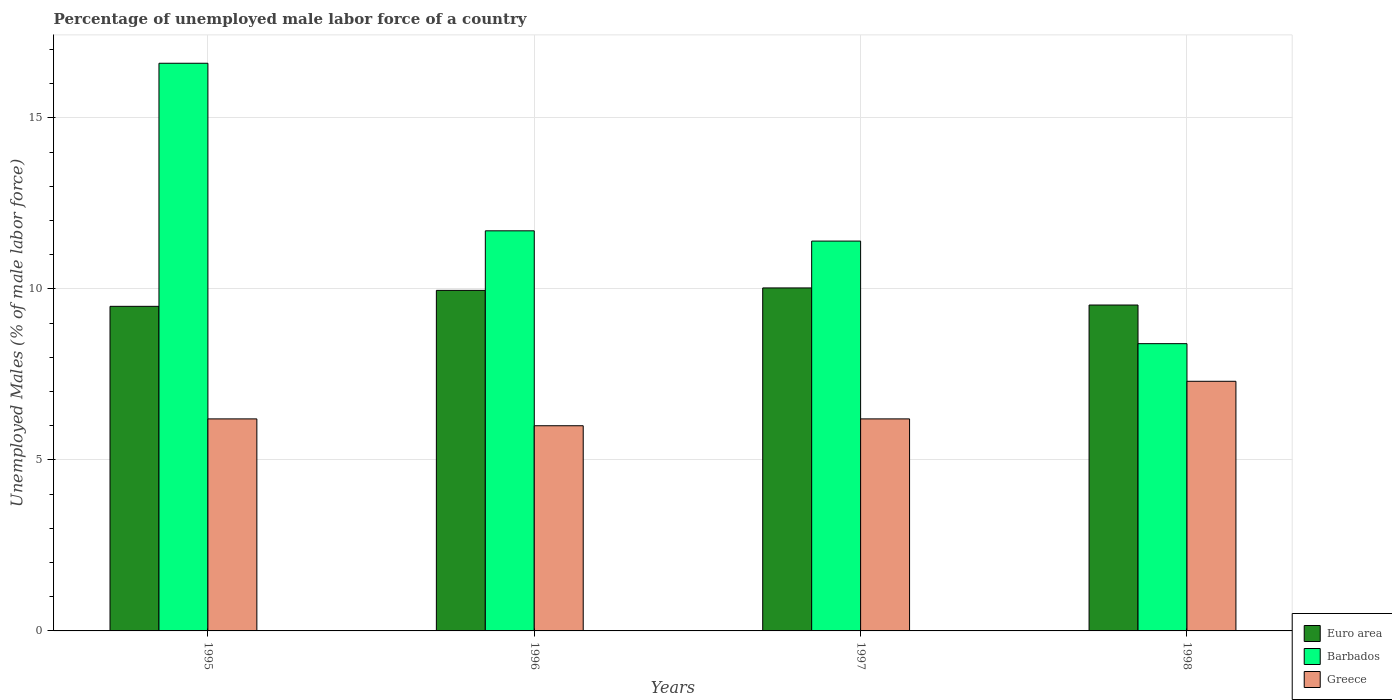How many groups of bars are there?
Provide a succinct answer. 4. Are the number of bars per tick equal to the number of legend labels?
Your answer should be very brief. Yes. Are the number of bars on each tick of the X-axis equal?
Provide a short and direct response. Yes. In how many cases, is the number of bars for a given year not equal to the number of legend labels?
Your answer should be compact. 0. What is the percentage of unemployed male labor force in Barbados in 1995?
Keep it short and to the point. 16.6. Across all years, what is the maximum percentage of unemployed male labor force in Greece?
Ensure brevity in your answer.  7.3. What is the total percentage of unemployed male labor force in Barbados in the graph?
Offer a terse response. 48.1. What is the difference between the percentage of unemployed male labor force in Euro area in 1996 and that in 1997?
Your response must be concise. -0.07. What is the difference between the percentage of unemployed male labor force in Euro area in 1998 and the percentage of unemployed male labor force in Barbados in 1996?
Make the answer very short. -2.17. What is the average percentage of unemployed male labor force in Barbados per year?
Your response must be concise. 12.02. In the year 1995, what is the difference between the percentage of unemployed male labor force in Greece and percentage of unemployed male labor force in Barbados?
Keep it short and to the point. -10.4. What is the ratio of the percentage of unemployed male labor force in Euro area in 1996 to that in 1998?
Offer a terse response. 1.04. Is the percentage of unemployed male labor force in Euro area in 1996 less than that in 1998?
Make the answer very short. No. Is the difference between the percentage of unemployed male labor force in Greece in 1995 and 1998 greater than the difference between the percentage of unemployed male labor force in Barbados in 1995 and 1998?
Offer a terse response. No. What is the difference between the highest and the second highest percentage of unemployed male labor force in Barbados?
Offer a terse response. 4.9. What is the difference between the highest and the lowest percentage of unemployed male labor force in Barbados?
Ensure brevity in your answer.  8.2. In how many years, is the percentage of unemployed male labor force in Barbados greater than the average percentage of unemployed male labor force in Barbados taken over all years?
Ensure brevity in your answer.  1. What does the 3rd bar from the left in 1996 represents?
Provide a short and direct response. Greece. What does the 2nd bar from the right in 1997 represents?
Your response must be concise. Barbados. Is it the case that in every year, the sum of the percentage of unemployed male labor force in Barbados and percentage of unemployed male labor force in Greece is greater than the percentage of unemployed male labor force in Euro area?
Ensure brevity in your answer.  Yes. How many bars are there?
Offer a very short reply. 12. Are all the bars in the graph horizontal?
Your answer should be very brief. No. How many years are there in the graph?
Offer a terse response. 4. What is the difference between two consecutive major ticks on the Y-axis?
Give a very brief answer. 5. Are the values on the major ticks of Y-axis written in scientific E-notation?
Ensure brevity in your answer.  No. Does the graph contain any zero values?
Give a very brief answer. No. Does the graph contain grids?
Your answer should be compact. Yes. Where does the legend appear in the graph?
Keep it short and to the point. Bottom right. How are the legend labels stacked?
Keep it short and to the point. Vertical. What is the title of the graph?
Make the answer very short. Percentage of unemployed male labor force of a country. What is the label or title of the Y-axis?
Your response must be concise. Unemployed Males (% of male labor force). What is the Unemployed Males (% of male labor force) in Euro area in 1995?
Offer a very short reply. 9.49. What is the Unemployed Males (% of male labor force) in Barbados in 1995?
Give a very brief answer. 16.6. What is the Unemployed Males (% of male labor force) in Greece in 1995?
Make the answer very short. 6.2. What is the Unemployed Males (% of male labor force) in Euro area in 1996?
Give a very brief answer. 9.96. What is the Unemployed Males (% of male labor force) of Barbados in 1996?
Provide a succinct answer. 11.7. What is the Unemployed Males (% of male labor force) in Euro area in 1997?
Offer a very short reply. 10.03. What is the Unemployed Males (% of male labor force) of Barbados in 1997?
Offer a terse response. 11.4. What is the Unemployed Males (% of male labor force) in Greece in 1997?
Provide a succinct answer. 6.2. What is the Unemployed Males (% of male labor force) in Euro area in 1998?
Make the answer very short. 9.53. What is the Unemployed Males (% of male labor force) in Barbados in 1998?
Offer a very short reply. 8.4. What is the Unemployed Males (% of male labor force) of Greece in 1998?
Keep it short and to the point. 7.3. Across all years, what is the maximum Unemployed Males (% of male labor force) in Euro area?
Keep it short and to the point. 10.03. Across all years, what is the maximum Unemployed Males (% of male labor force) in Barbados?
Ensure brevity in your answer.  16.6. Across all years, what is the maximum Unemployed Males (% of male labor force) of Greece?
Provide a short and direct response. 7.3. Across all years, what is the minimum Unemployed Males (% of male labor force) in Euro area?
Your response must be concise. 9.49. Across all years, what is the minimum Unemployed Males (% of male labor force) in Barbados?
Make the answer very short. 8.4. Across all years, what is the minimum Unemployed Males (% of male labor force) in Greece?
Give a very brief answer. 6. What is the total Unemployed Males (% of male labor force) in Euro area in the graph?
Provide a short and direct response. 39.01. What is the total Unemployed Males (% of male labor force) of Barbados in the graph?
Offer a terse response. 48.1. What is the total Unemployed Males (% of male labor force) in Greece in the graph?
Provide a succinct answer. 25.7. What is the difference between the Unemployed Males (% of male labor force) of Euro area in 1995 and that in 1996?
Make the answer very short. -0.47. What is the difference between the Unemployed Males (% of male labor force) of Barbados in 1995 and that in 1996?
Offer a terse response. 4.9. What is the difference between the Unemployed Males (% of male labor force) in Euro area in 1995 and that in 1997?
Ensure brevity in your answer.  -0.54. What is the difference between the Unemployed Males (% of male labor force) of Barbados in 1995 and that in 1997?
Provide a short and direct response. 5.2. What is the difference between the Unemployed Males (% of male labor force) in Greece in 1995 and that in 1997?
Your answer should be very brief. 0. What is the difference between the Unemployed Males (% of male labor force) of Euro area in 1995 and that in 1998?
Make the answer very short. -0.04. What is the difference between the Unemployed Males (% of male labor force) of Euro area in 1996 and that in 1997?
Provide a succinct answer. -0.07. What is the difference between the Unemployed Males (% of male labor force) in Barbados in 1996 and that in 1997?
Your answer should be compact. 0.3. What is the difference between the Unemployed Males (% of male labor force) of Euro area in 1996 and that in 1998?
Offer a terse response. 0.43. What is the difference between the Unemployed Males (% of male labor force) of Euro area in 1997 and that in 1998?
Ensure brevity in your answer.  0.5. What is the difference between the Unemployed Males (% of male labor force) in Euro area in 1995 and the Unemployed Males (% of male labor force) in Barbados in 1996?
Your answer should be very brief. -2.21. What is the difference between the Unemployed Males (% of male labor force) in Euro area in 1995 and the Unemployed Males (% of male labor force) in Greece in 1996?
Your response must be concise. 3.49. What is the difference between the Unemployed Males (% of male labor force) of Euro area in 1995 and the Unemployed Males (% of male labor force) of Barbados in 1997?
Make the answer very short. -1.91. What is the difference between the Unemployed Males (% of male labor force) of Euro area in 1995 and the Unemployed Males (% of male labor force) of Greece in 1997?
Keep it short and to the point. 3.29. What is the difference between the Unemployed Males (% of male labor force) of Barbados in 1995 and the Unemployed Males (% of male labor force) of Greece in 1997?
Ensure brevity in your answer.  10.4. What is the difference between the Unemployed Males (% of male labor force) in Euro area in 1995 and the Unemployed Males (% of male labor force) in Barbados in 1998?
Make the answer very short. 1.09. What is the difference between the Unemployed Males (% of male labor force) in Euro area in 1995 and the Unemployed Males (% of male labor force) in Greece in 1998?
Offer a terse response. 2.19. What is the difference between the Unemployed Males (% of male labor force) in Barbados in 1995 and the Unemployed Males (% of male labor force) in Greece in 1998?
Give a very brief answer. 9.3. What is the difference between the Unemployed Males (% of male labor force) of Euro area in 1996 and the Unemployed Males (% of male labor force) of Barbados in 1997?
Offer a very short reply. -1.44. What is the difference between the Unemployed Males (% of male labor force) in Euro area in 1996 and the Unemployed Males (% of male labor force) in Greece in 1997?
Your answer should be compact. 3.76. What is the difference between the Unemployed Males (% of male labor force) of Euro area in 1996 and the Unemployed Males (% of male labor force) of Barbados in 1998?
Offer a very short reply. 1.56. What is the difference between the Unemployed Males (% of male labor force) of Euro area in 1996 and the Unemployed Males (% of male labor force) of Greece in 1998?
Your answer should be very brief. 2.66. What is the difference between the Unemployed Males (% of male labor force) in Euro area in 1997 and the Unemployed Males (% of male labor force) in Barbados in 1998?
Offer a very short reply. 1.63. What is the difference between the Unemployed Males (% of male labor force) of Euro area in 1997 and the Unemployed Males (% of male labor force) of Greece in 1998?
Your answer should be very brief. 2.73. What is the average Unemployed Males (% of male labor force) in Euro area per year?
Offer a very short reply. 9.75. What is the average Unemployed Males (% of male labor force) in Barbados per year?
Provide a succinct answer. 12.03. What is the average Unemployed Males (% of male labor force) of Greece per year?
Your answer should be very brief. 6.42. In the year 1995, what is the difference between the Unemployed Males (% of male labor force) of Euro area and Unemployed Males (% of male labor force) of Barbados?
Provide a short and direct response. -7.11. In the year 1995, what is the difference between the Unemployed Males (% of male labor force) in Euro area and Unemployed Males (% of male labor force) in Greece?
Your answer should be very brief. 3.29. In the year 1995, what is the difference between the Unemployed Males (% of male labor force) of Barbados and Unemployed Males (% of male labor force) of Greece?
Your answer should be very brief. 10.4. In the year 1996, what is the difference between the Unemployed Males (% of male labor force) in Euro area and Unemployed Males (% of male labor force) in Barbados?
Your answer should be compact. -1.74. In the year 1996, what is the difference between the Unemployed Males (% of male labor force) in Euro area and Unemployed Males (% of male labor force) in Greece?
Your response must be concise. 3.96. In the year 1996, what is the difference between the Unemployed Males (% of male labor force) in Barbados and Unemployed Males (% of male labor force) in Greece?
Your answer should be compact. 5.7. In the year 1997, what is the difference between the Unemployed Males (% of male labor force) in Euro area and Unemployed Males (% of male labor force) in Barbados?
Offer a very short reply. -1.37. In the year 1997, what is the difference between the Unemployed Males (% of male labor force) of Euro area and Unemployed Males (% of male labor force) of Greece?
Keep it short and to the point. 3.83. In the year 1998, what is the difference between the Unemployed Males (% of male labor force) in Euro area and Unemployed Males (% of male labor force) in Barbados?
Keep it short and to the point. 1.13. In the year 1998, what is the difference between the Unemployed Males (% of male labor force) in Euro area and Unemployed Males (% of male labor force) in Greece?
Ensure brevity in your answer.  2.23. What is the ratio of the Unemployed Males (% of male labor force) in Euro area in 1995 to that in 1996?
Provide a succinct answer. 0.95. What is the ratio of the Unemployed Males (% of male labor force) of Barbados in 1995 to that in 1996?
Your answer should be compact. 1.42. What is the ratio of the Unemployed Males (% of male labor force) in Euro area in 1995 to that in 1997?
Ensure brevity in your answer.  0.95. What is the ratio of the Unemployed Males (% of male labor force) of Barbados in 1995 to that in 1997?
Make the answer very short. 1.46. What is the ratio of the Unemployed Males (% of male labor force) in Greece in 1995 to that in 1997?
Make the answer very short. 1. What is the ratio of the Unemployed Males (% of male labor force) of Euro area in 1995 to that in 1998?
Offer a very short reply. 1. What is the ratio of the Unemployed Males (% of male labor force) of Barbados in 1995 to that in 1998?
Offer a very short reply. 1.98. What is the ratio of the Unemployed Males (% of male labor force) of Greece in 1995 to that in 1998?
Ensure brevity in your answer.  0.85. What is the ratio of the Unemployed Males (% of male labor force) in Barbados in 1996 to that in 1997?
Keep it short and to the point. 1.03. What is the ratio of the Unemployed Males (% of male labor force) in Euro area in 1996 to that in 1998?
Ensure brevity in your answer.  1.04. What is the ratio of the Unemployed Males (% of male labor force) of Barbados in 1996 to that in 1998?
Give a very brief answer. 1.39. What is the ratio of the Unemployed Males (% of male labor force) of Greece in 1996 to that in 1998?
Offer a very short reply. 0.82. What is the ratio of the Unemployed Males (% of male labor force) in Euro area in 1997 to that in 1998?
Provide a short and direct response. 1.05. What is the ratio of the Unemployed Males (% of male labor force) in Barbados in 1997 to that in 1998?
Make the answer very short. 1.36. What is the ratio of the Unemployed Males (% of male labor force) in Greece in 1997 to that in 1998?
Provide a succinct answer. 0.85. What is the difference between the highest and the second highest Unemployed Males (% of male labor force) of Euro area?
Offer a very short reply. 0.07. What is the difference between the highest and the lowest Unemployed Males (% of male labor force) of Euro area?
Keep it short and to the point. 0.54. What is the difference between the highest and the lowest Unemployed Males (% of male labor force) in Barbados?
Keep it short and to the point. 8.2. 